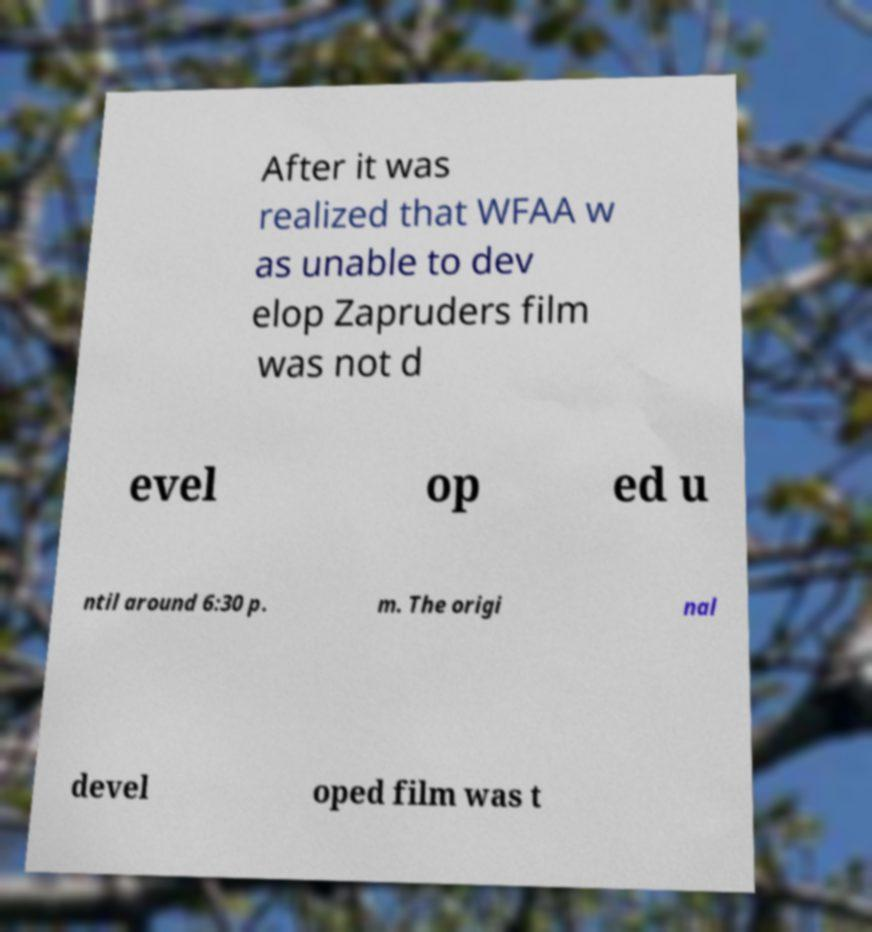Please read and relay the text visible in this image. What does it say? After it was realized that WFAA w as unable to dev elop Zapruders film was not d evel op ed u ntil around 6:30 p. m. The origi nal devel oped film was t 